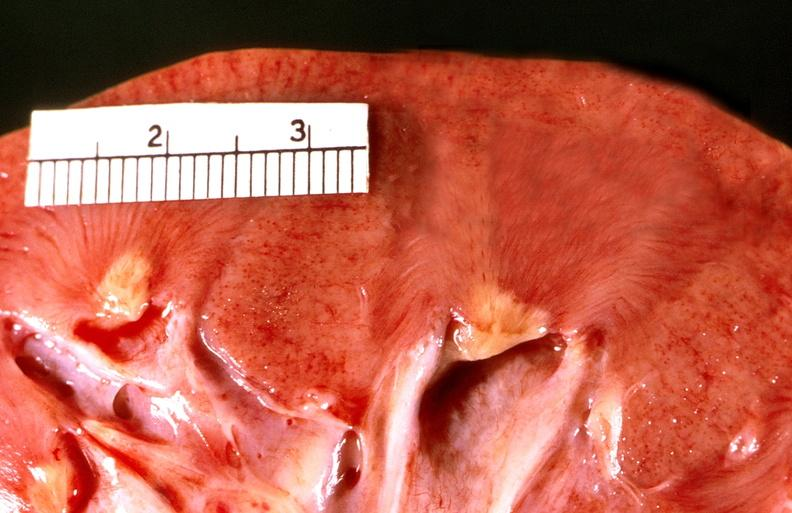what does this image show?
Answer the question using a single word or phrase. Renal papillary necrosis 